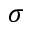Convert formula to latex. <formula><loc_0><loc_0><loc_500><loc_500>\sigma</formula> 